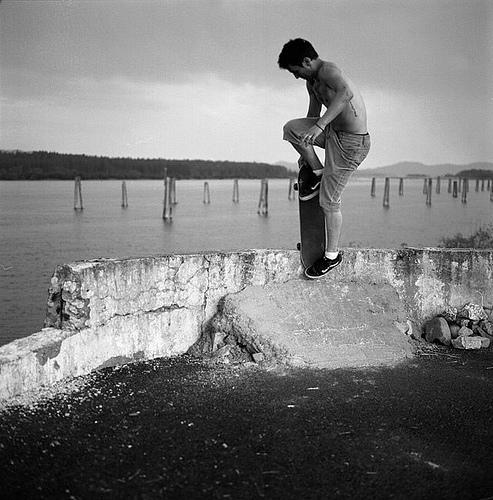What is the man doing?
Be succinct. Skateboarding. Can you see water?
Quick response, please. Yes. Is he wearing a shirt?
Be succinct. No. 